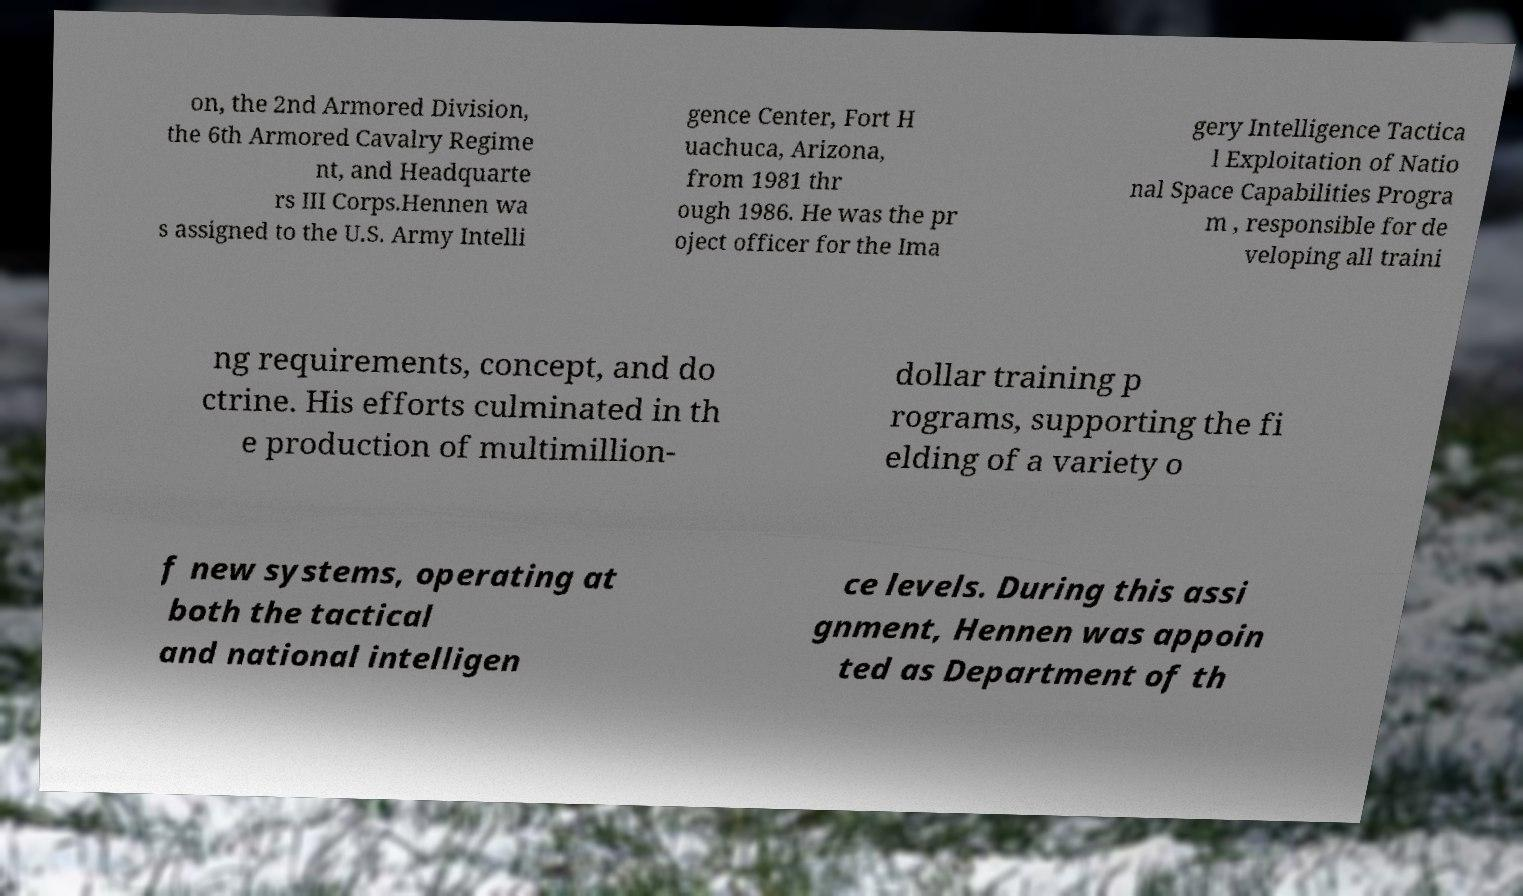Please read and relay the text visible in this image. What does it say? on, the 2nd Armored Division, the 6th Armored Cavalry Regime nt, and Headquarte rs III Corps.Hennen wa s assigned to the U.S. Army Intelli gence Center, Fort H uachuca, Arizona, from 1981 thr ough 1986. He was the pr oject officer for the Ima gery Intelligence Tactica l Exploitation of Natio nal Space Capabilities Progra m , responsible for de veloping all traini ng requirements, concept, and do ctrine. His efforts culminated in th e production of multimillion- dollar training p rograms, supporting the fi elding of a variety o f new systems, operating at both the tactical and national intelligen ce levels. During this assi gnment, Hennen was appoin ted as Department of th 